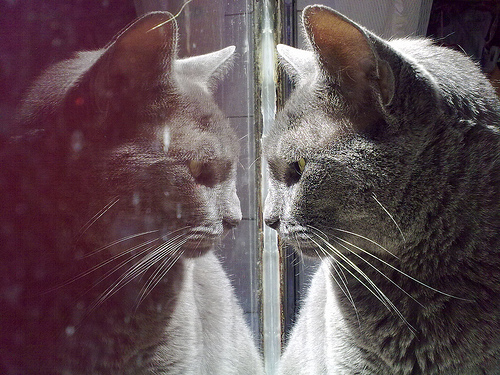<image>
Is the cat behind the mirror? No. The cat is not behind the mirror. From this viewpoint, the cat appears to be positioned elsewhere in the scene. Is there a cat in front of the cat? Yes. The cat is positioned in front of the cat, appearing closer to the camera viewpoint. 